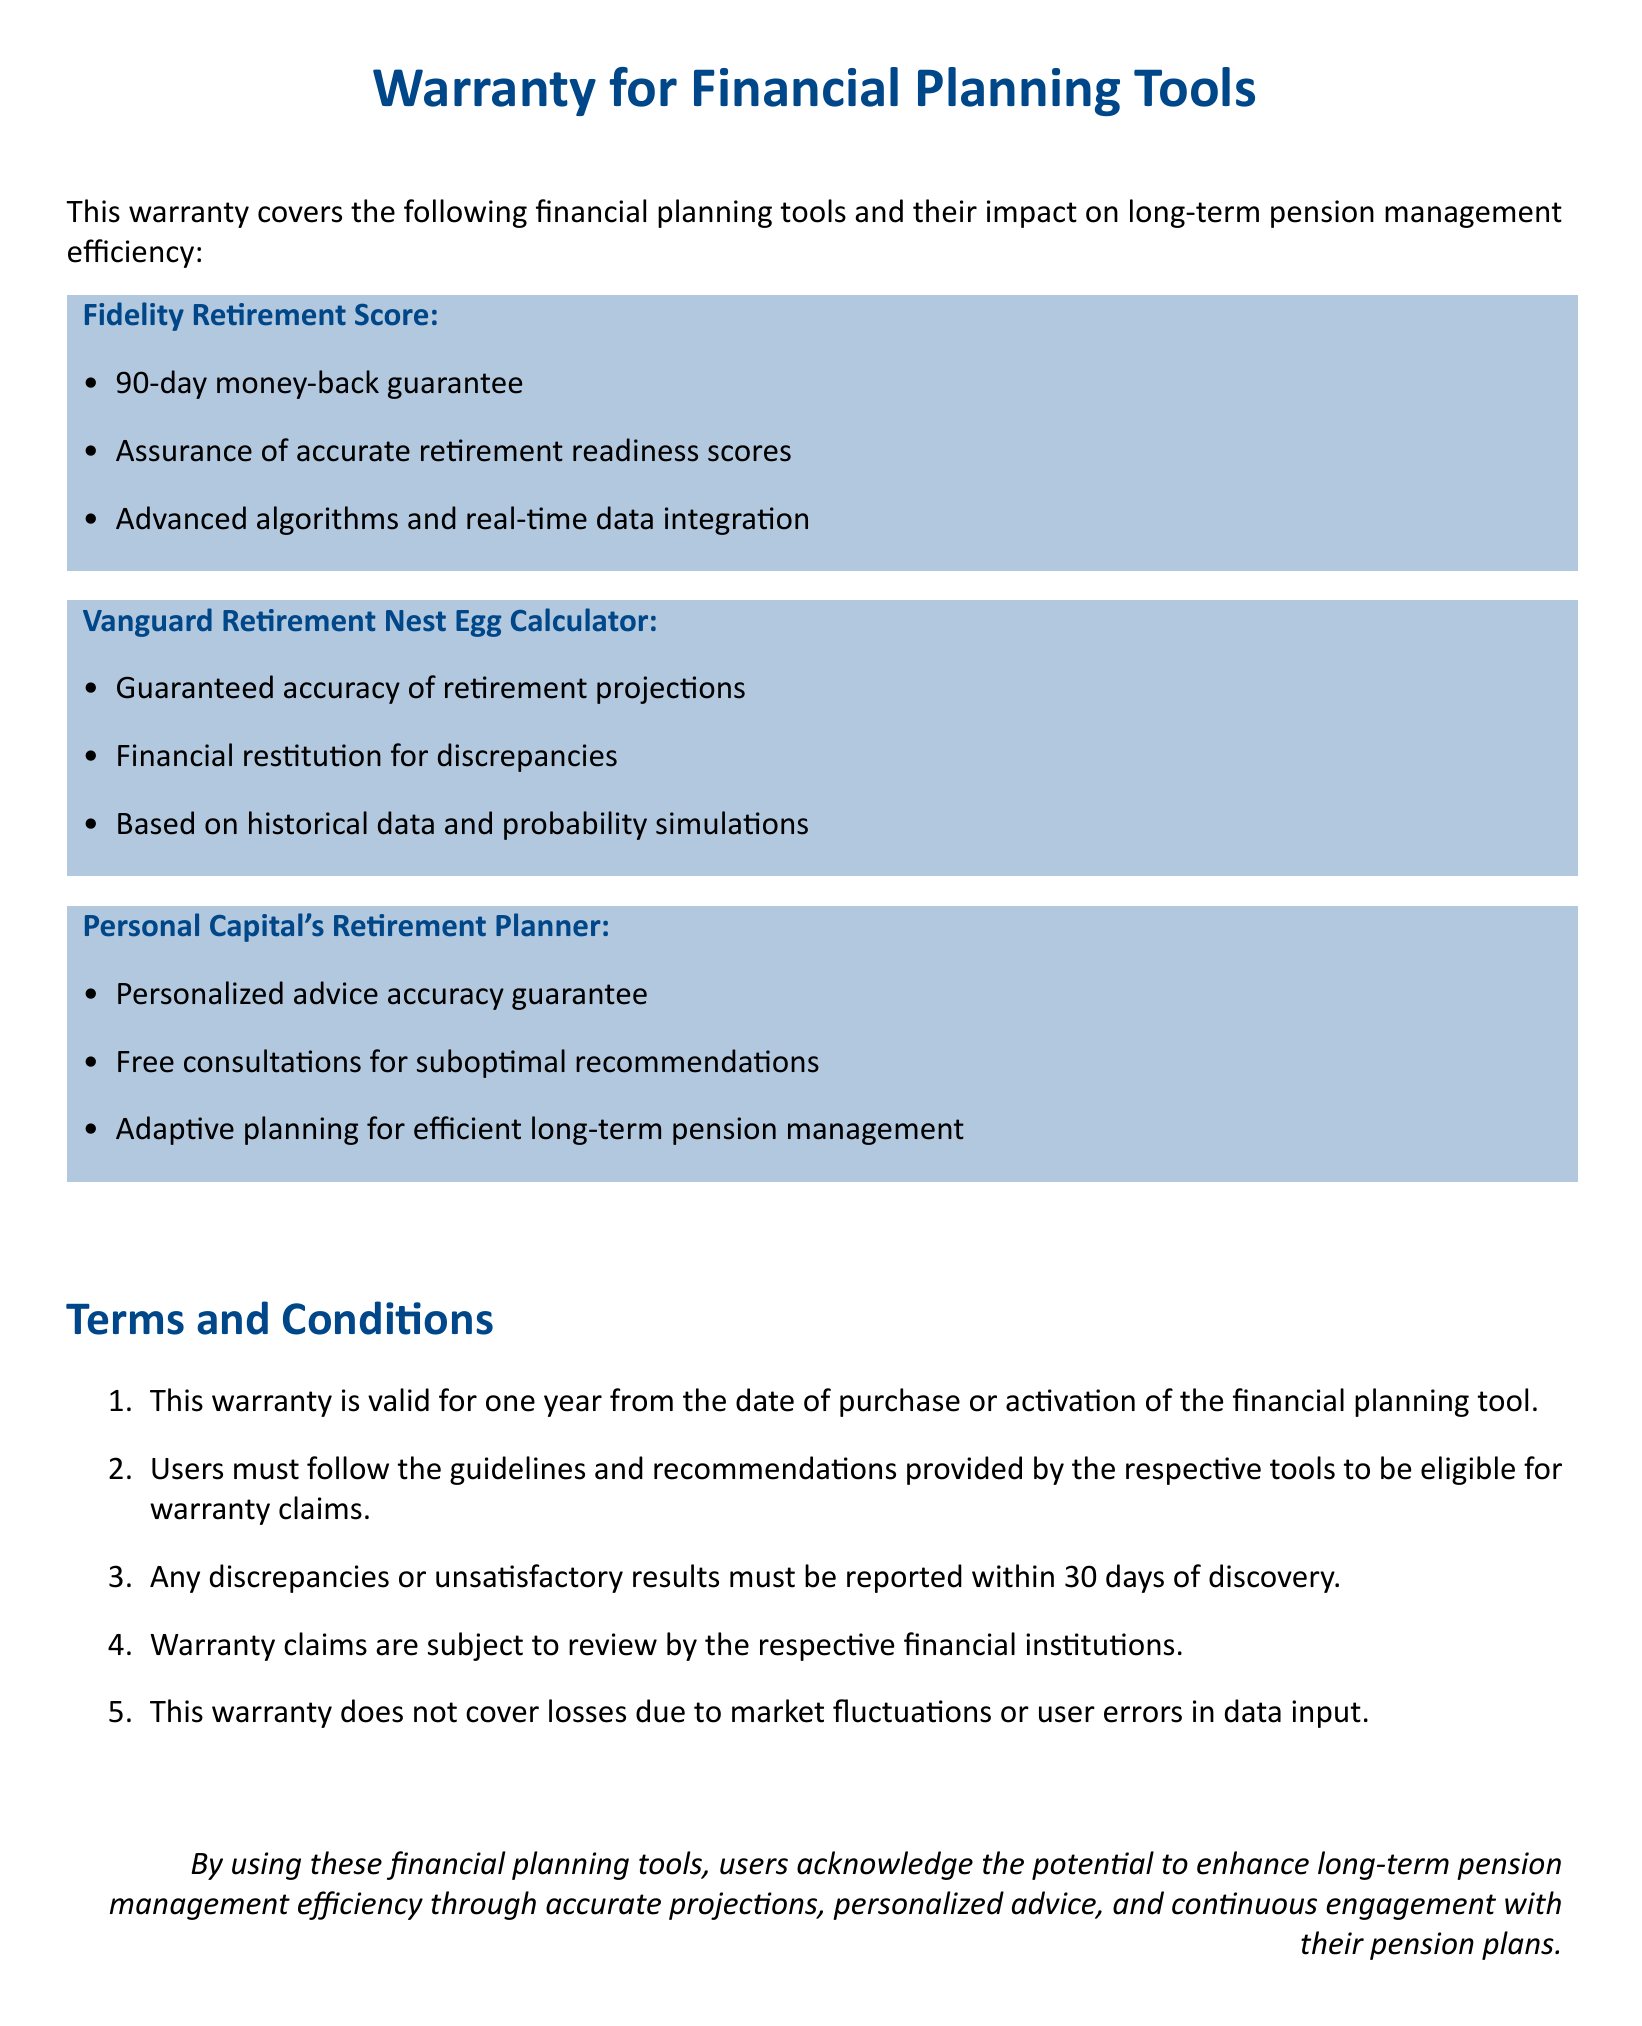What is the warranty period for these financial planning tools? The warranty is valid for one year from the date of purchase or activation of the financial planning tool.
Answer: one year What is the money-back guarantee period for Fidelity Retirement Score? The Fidelity Retirement Score includes a 90-day money-back guarantee.
Answer: 90 days What must users do to be eligible for warranty claims? Users must follow the guidelines and recommendations provided by the respective tools to be eligible for warranty claims.
Answer: follow guidelines What type of guarantee does Personal Capital's Retirement Planner offer? It offers a personalized advice accuracy guarantee.
Answer: accuracy guarantee What compensation is provided by Vanguard Retirement Nest Egg Calculator for discrepancies? Financial restitution is provided for discrepancies.
Answer: financial restitution What is a condition for reporting discrepancies? Discrepancies or unsatisfactory results must be reported within 30 days of discovery.
Answer: 30 days Which financial planning tool requires free consultations for suboptimal recommendations? Personal Capital's Retirement Planner requires free consultations for suboptimal recommendations.
Answer: Personal Capital's Retirement Planner What is not covered by the warranty? Warranty does not cover losses due to market fluctuations or user errors in data input.
Answer: market fluctuations 